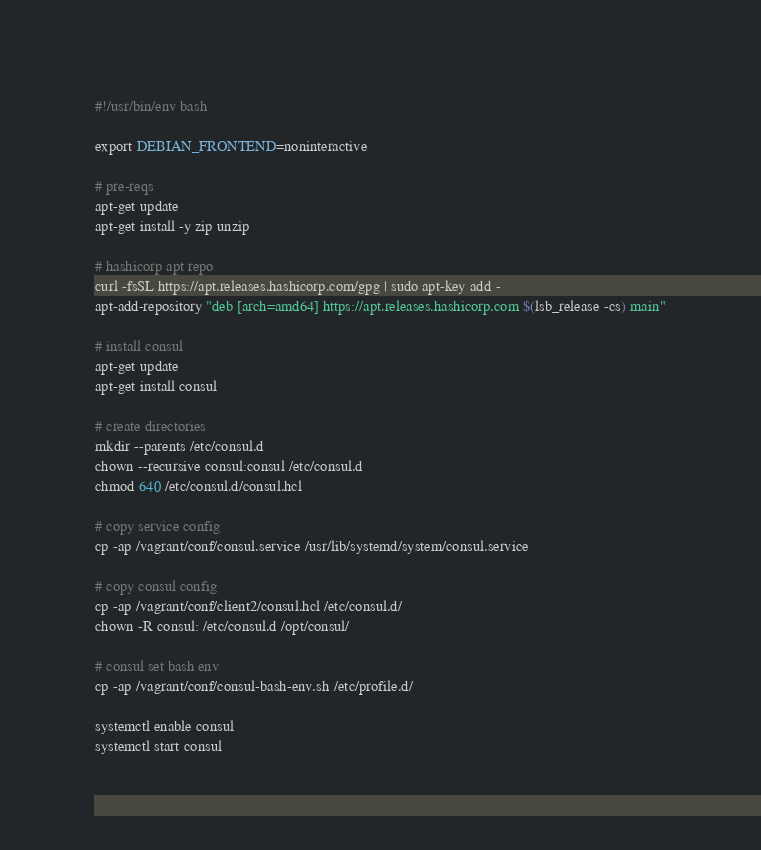<code> <loc_0><loc_0><loc_500><loc_500><_Bash_>#!/usr/bin/env bash

export DEBIAN_FRONTEND=noninteractive

# pre-reqs
apt-get update
apt-get install -y zip unzip

# hashicorp apt repo
curl -fsSL https://apt.releases.hashicorp.com/gpg | sudo apt-key add -
apt-add-repository "deb [arch=amd64] https://apt.releases.hashicorp.com $(lsb_release -cs) main"

# install consul
apt-get update
apt-get install consul

# create directories
mkdir --parents /etc/consul.d
chown --recursive consul:consul /etc/consul.d
chmod 640 /etc/consul.d/consul.hcl

# copy service config
cp -ap /vagrant/conf/consul.service /usr/lib/systemd/system/consul.service

# copy consul config
cp -ap /vagrant/conf/client2/consul.hcl /etc/consul.d/
chown -R consul: /etc/consul.d /opt/consul/

# consul set bash env
cp -ap /vagrant/conf/consul-bash-env.sh /etc/profile.d/

systemctl enable consul
systemctl start consul
</code> 